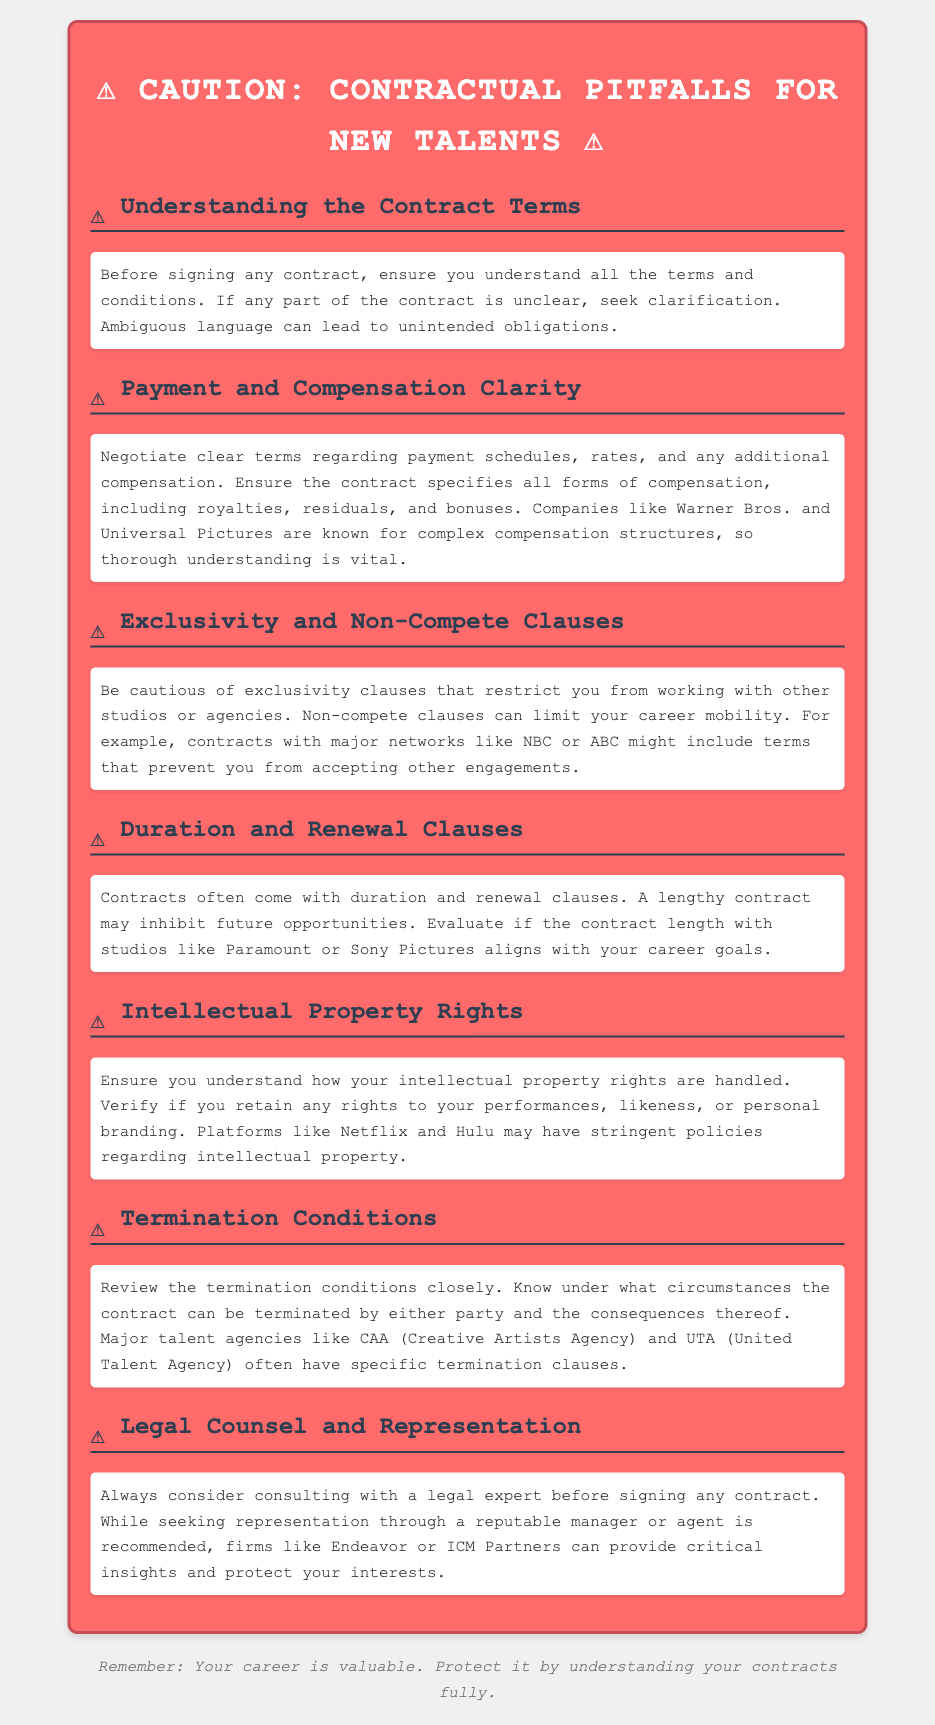What is the caution label's main focus? The main focus of the caution label is to alert new talents about potential contractual pitfalls.
Answer: Contractual Pitfalls What should new talents understand before signing a contract? New talents should understand all the terms and conditions of the contract before signing.
Answer: Contract Terms Which major companies are mentioned regarding complex compensation structures? The document specifically mentions Warner Bros. and Universal Pictures in the context of complex compensation structures.
Answer: Warner Bros. and Universal Pictures What type of clauses should talents be cautious of that restrict working with others? Talents should be cautious of exclusivity clauses that restrict them from working with other studios or agencies.
Answer: Exclusivity clauses What should be reviewed closely in a contract according to the document? The termination conditions should be reviewed closely, including the circumstances for termination and its consequences.
Answer: Termination Conditions Who should talents consider consulting before signing a contract? Talents should consider consulting with a legal expert before signing any contracts.
Answer: Legal expert What might a lengthy contract inhibit according to the warning label? A lengthy contract may inhibit future opportunities for new talents.
Answer: Future opportunities Which platforms may have strict rules regarding intellectual property? The warning label mentions Netflix and Hulu as platforms with stringent policies regarding intellectual property.
Answer: Netflix and Hulu 